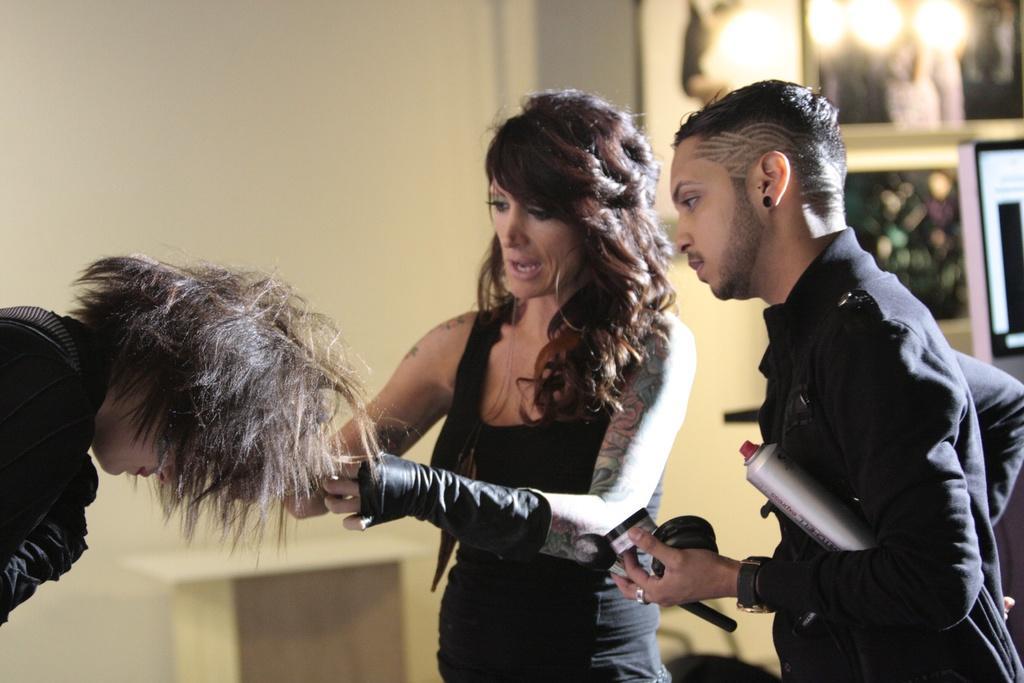How would you summarize this image in a sentence or two? In this image there is a woman in the middle who is doing the hairstyle to the person who is in front of her. On the right side there is a man who is standing by holding the creams and bottles. In the background there is a wall. At the top there are lights. 